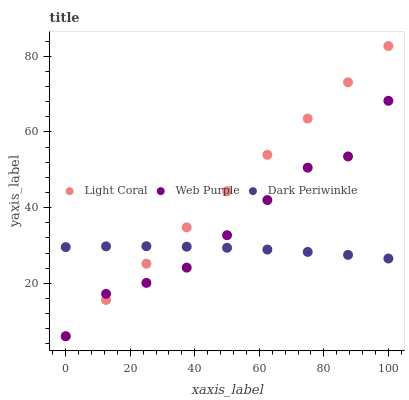Does Dark Periwinkle have the minimum area under the curve?
Answer yes or no. Yes. Does Light Coral have the maximum area under the curve?
Answer yes or no. Yes. Does Web Purple have the minimum area under the curve?
Answer yes or no. No. Does Web Purple have the maximum area under the curve?
Answer yes or no. No. Is Light Coral the smoothest?
Answer yes or no. Yes. Is Web Purple the roughest?
Answer yes or no. Yes. Is Dark Periwinkle the smoothest?
Answer yes or no. No. Is Dark Periwinkle the roughest?
Answer yes or no. No. Does Light Coral have the lowest value?
Answer yes or no. Yes. Does Dark Periwinkle have the lowest value?
Answer yes or no. No. Does Light Coral have the highest value?
Answer yes or no. Yes. Does Web Purple have the highest value?
Answer yes or no. No. Does Web Purple intersect Light Coral?
Answer yes or no. Yes. Is Web Purple less than Light Coral?
Answer yes or no. No. Is Web Purple greater than Light Coral?
Answer yes or no. No. 